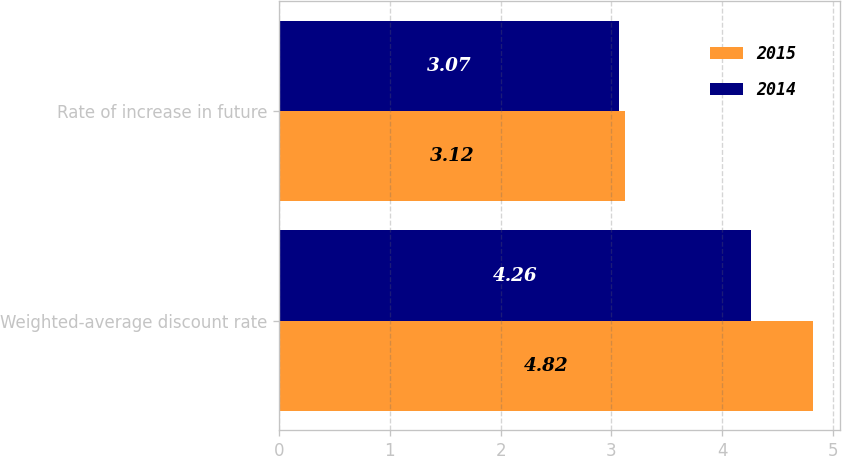<chart> <loc_0><loc_0><loc_500><loc_500><stacked_bar_chart><ecel><fcel>Weighted-average discount rate<fcel>Rate of increase in future<nl><fcel>2015<fcel>4.82<fcel>3.12<nl><fcel>2014<fcel>4.26<fcel>3.07<nl></chart> 